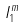<formula> <loc_0><loc_0><loc_500><loc_500>I _ { 1 } ^ { m }</formula> 